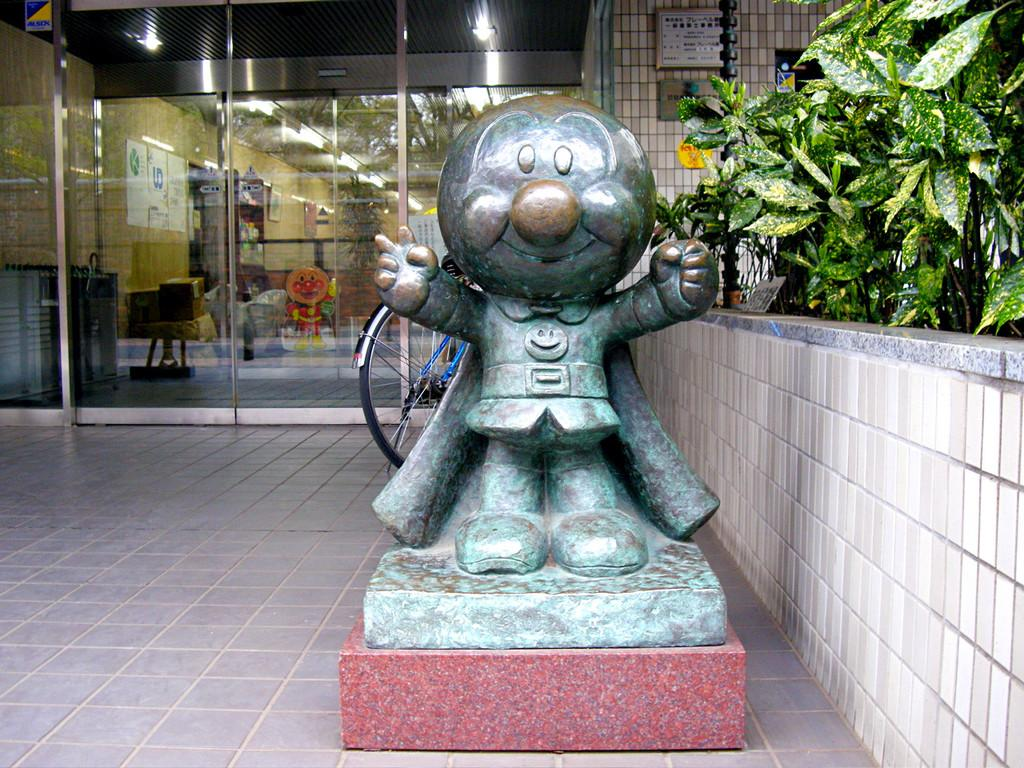What is the main subject in the image? There is a sculpture in the image. What can be seen in the background of the image? There is a bicycle and plants in the background of the image. What type of structure is present in the image? There is a glass door in the image. What is visible at the bottom of the image? The floor is visible at the bottom of the image. How many apples are connected to the sculpture in the image? There are no apples present in the image, and therefore no connection to the sculpture can be observed. 